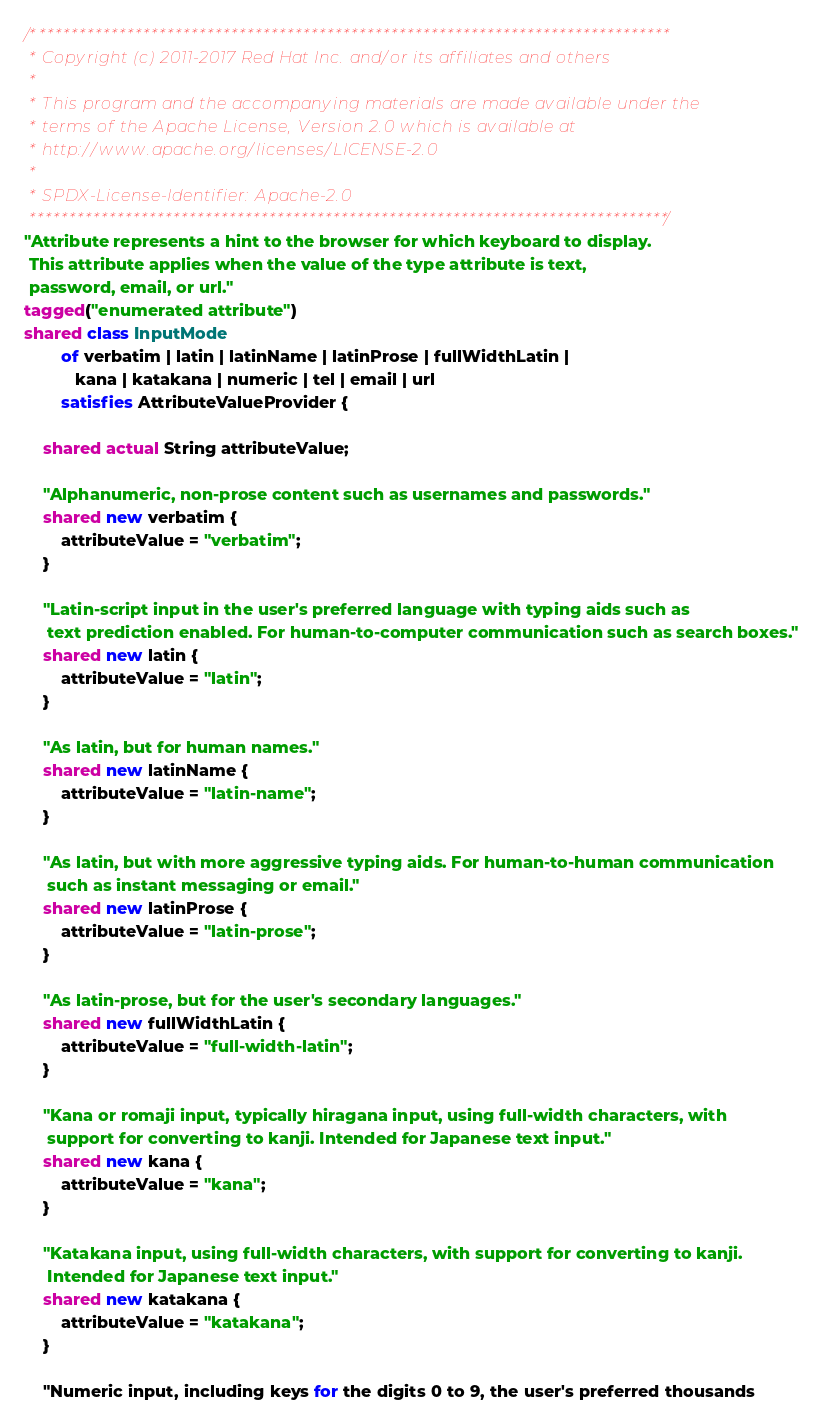<code> <loc_0><loc_0><loc_500><loc_500><_Ceylon_>/********************************************************************************
 * Copyright (c) 2011-2017 Red Hat Inc. and/or its affiliates and others
 *
 * This program and the accompanying materials are made available under the 
 * terms of the Apache License, Version 2.0 which is available at
 * http://www.apache.org/licenses/LICENSE-2.0
 *
 * SPDX-License-Identifier: Apache-2.0 
 ********************************************************************************/
"Attribute represents a hint to the browser for which keyboard to display. 
 This attribute applies when the value of the type attribute is text, 
 password, email, or url."
tagged("enumerated attribute")
shared class InputMode
        of verbatim | latin | latinName | latinProse | fullWidthLatin | 
           kana | katakana | numeric | tel | email | url
        satisfies AttributeValueProvider {
    
    shared actual String attributeValue;
    
    "Alphanumeric, non-prose content such as usernames and passwords."
    shared new verbatim {
        attributeValue = "verbatim"; 
    }
    
    "Latin-script input in the user's preferred language with typing aids such as 
     text prediction enabled. For human-to-computer communication such as search boxes."
    shared new latin {
        attributeValue = "latin";
    }
    
    "As latin, but for human names."
    shared new latinName {
        attributeValue = "latin-name";
    }
    
    "As latin, but with more aggressive typing aids. For human-to-human communication 
     such as instant messaging or email."
    shared new latinProse {
        attributeValue = "latin-prose";
    }
    
    "As latin-prose, but for the user's secondary languages."
    shared new fullWidthLatin {
        attributeValue = "full-width-latin";
    }
    
    "Kana or romaji input, typically hiragana input, using full-width characters, with 
     support for converting to kanji. Intended for Japanese text input."
    shared new kana {
        attributeValue = "kana";
    }
    
    "Katakana input, using full-width characters, with support for converting to kanji. 
     Intended for Japanese text input."
    shared new katakana {
        attributeValue = "katakana";
    }
    
    "Numeric input, including keys for the digits 0 to 9, the user's preferred thousands </code> 